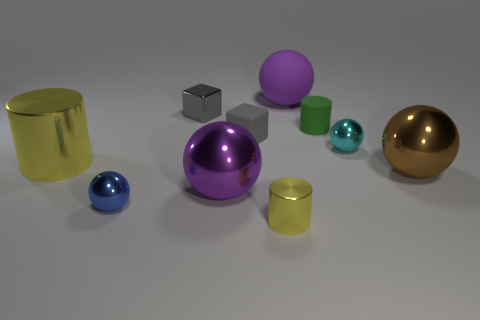What number of other things are there of the same size as the purple rubber ball?
Provide a succinct answer. 3. What number of things are large metallic spheres that are left of the brown thing or cylinders that are behind the tiny yellow metallic thing?
Your answer should be very brief. 3. There is a green object that is the same size as the gray shiny thing; what shape is it?
Ensure brevity in your answer.  Cylinder. There is a yellow thing that is the same material as the large yellow cylinder; what size is it?
Ensure brevity in your answer.  Small. Does the green matte object have the same shape as the blue shiny thing?
Ensure brevity in your answer.  No. What is the color of the rubber cylinder that is the same size as the gray rubber cube?
Your answer should be very brief. Green. What is the size of the cyan thing that is the same shape as the big purple rubber thing?
Provide a succinct answer. Small. There is a gray thing that is to the left of the tiny matte block; what is its shape?
Ensure brevity in your answer.  Cube. There is a green rubber thing; is its shape the same as the metal thing behind the green rubber cylinder?
Your answer should be very brief. No. Is the number of purple things that are in front of the big matte ball the same as the number of large spheres in front of the green matte thing?
Give a very brief answer. No. 